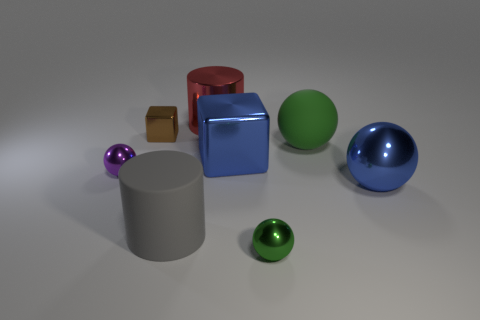Subtract 1 spheres. How many spheres are left? 3 Subtract all blue cubes. Subtract all yellow spheres. How many cubes are left? 1 Add 2 big green things. How many objects exist? 10 Subtract all cylinders. How many objects are left? 6 Subtract 0 green cylinders. How many objects are left? 8 Subtract all tiny brown things. Subtract all red cylinders. How many objects are left? 6 Add 3 blocks. How many blocks are left? 5 Add 4 purple metallic things. How many purple metallic things exist? 5 